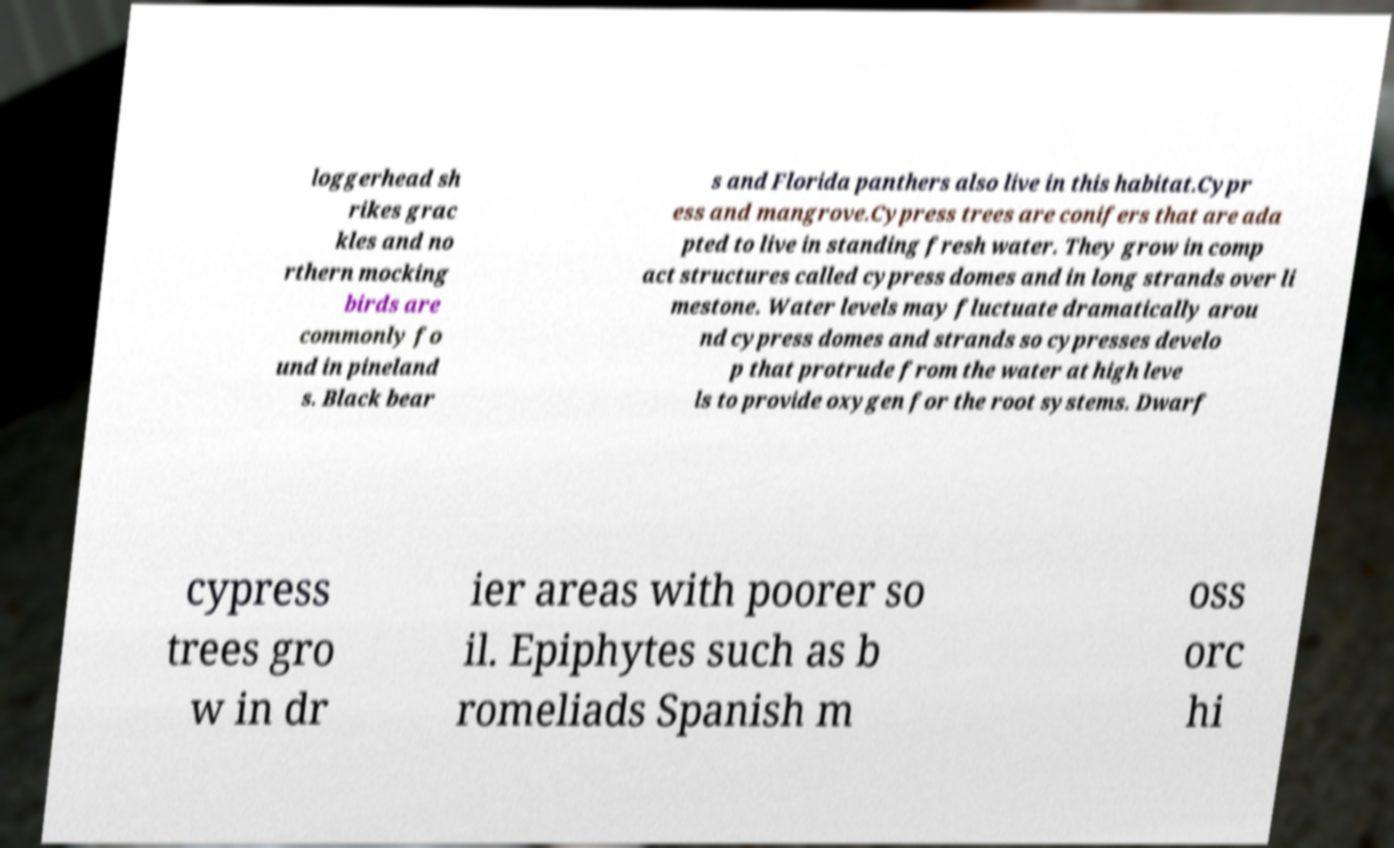I need the written content from this picture converted into text. Can you do that? loggerhead sh rikes grac kles and no rthern mocking birds are commonly fo und in pineland s. Black bear s and Florida panthers also live in this habitat.Cypr ess and mangrove.Cypress trees are conifers that are ada pted to live in standing fresh water. They grow in comp act structures called cypress domes and in long strands over li mestone. Water levels may fluctuate dramatically arou nd cypress domes and strands so cypresses develo p that protrude from the water at high leve ls to provide oxygen for the root systems. Dwarf cypress trees gro w in dr ier areas with poorer so il. Epiphytes such as b romeliads Spanish m oss orc hi 